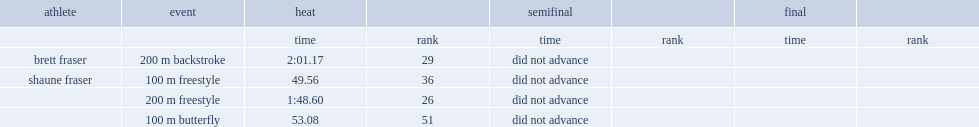What was the result did fraser complete his 200 m backstroke event with a time of? 2:01.17. 